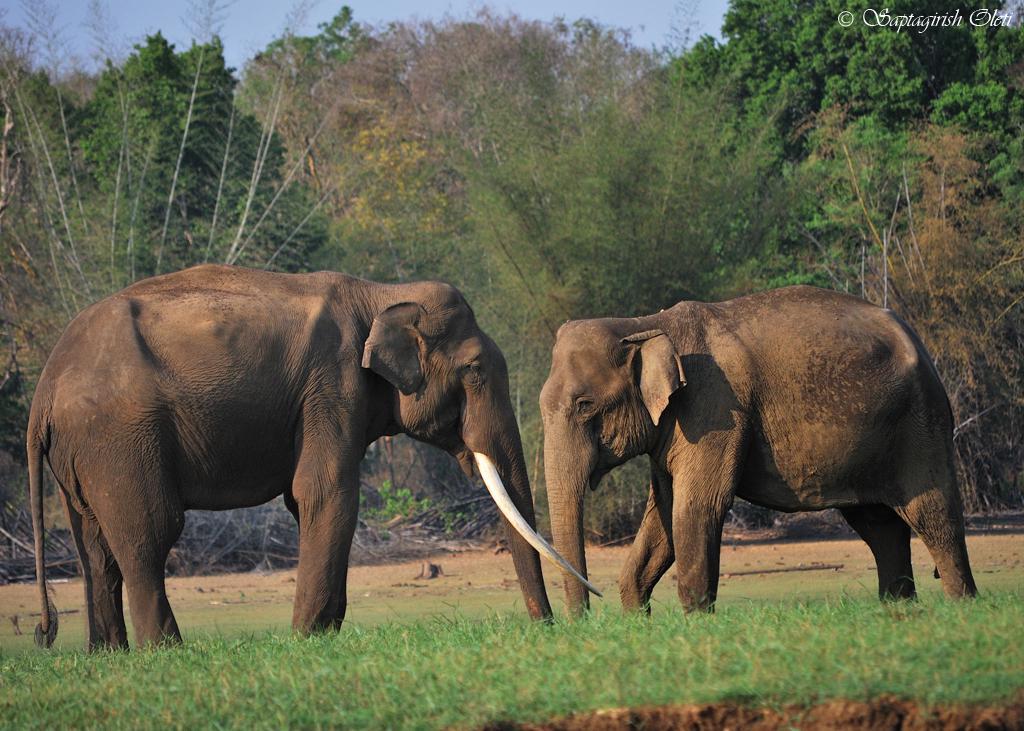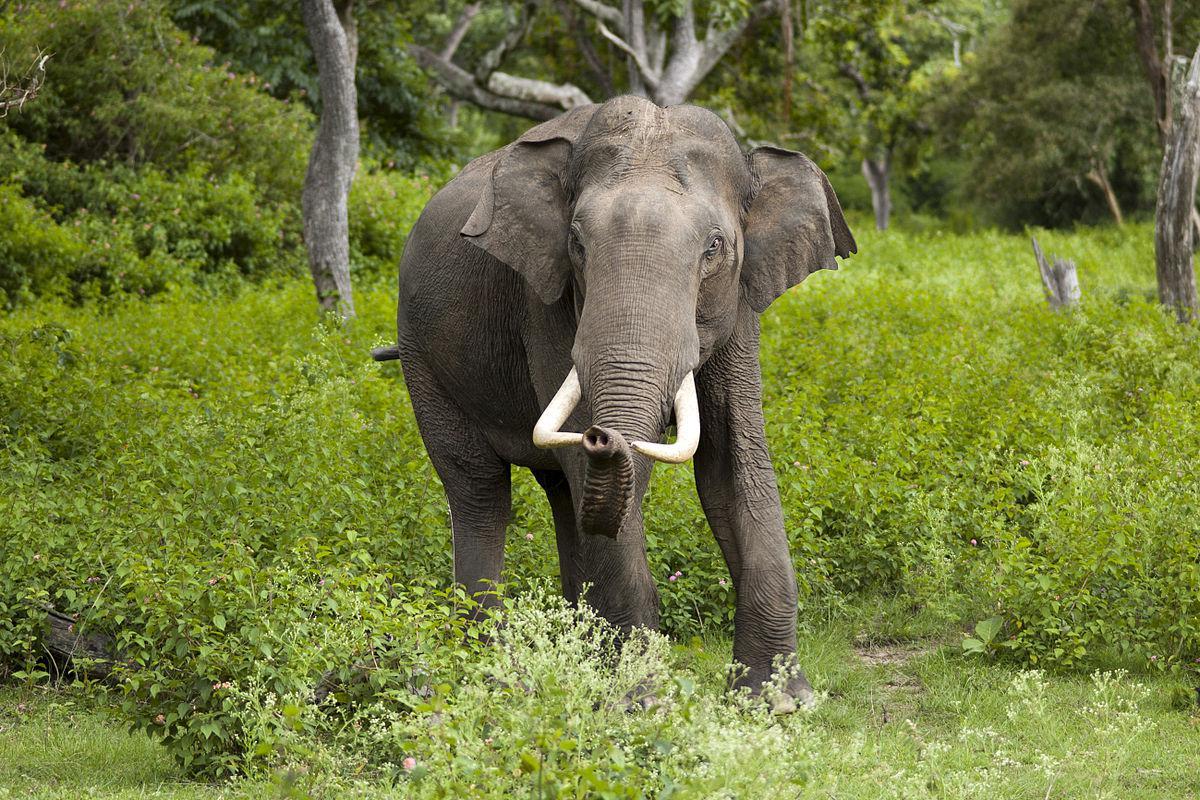The first image is the image on the left, the second image is the image on the right. Evaluate the accuracy of this statement regarding the images: "The animals in the image on the left are standing in the water.". Is it true? Answer yes or no. No. 